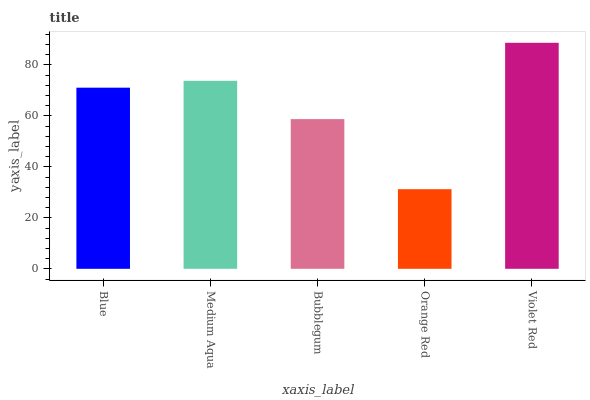Is Medium Aqua the minimum?
Answer yes or no. No. Is Medium Aqua the maximum?
Answer yes or no. No. Is Medium Aqua greater than Blue?
Answer yes or no. Yes. Is Blue less than Medium Aqua?
Answer yes or no. Yes. Is Blue greater than Medium Aqua?
Answer yes or no. No. Is Medium Aqua less than Blue?
Answer yes or no. No. Is Blue the high median?
Answer yes or no. Yes. Is Blue the low median?
Answer yes or no. Yes. Is Bubblegum the high median?
Answer yes or no. No. Is Bubblegum the low median?
Answer yes or no. No. 